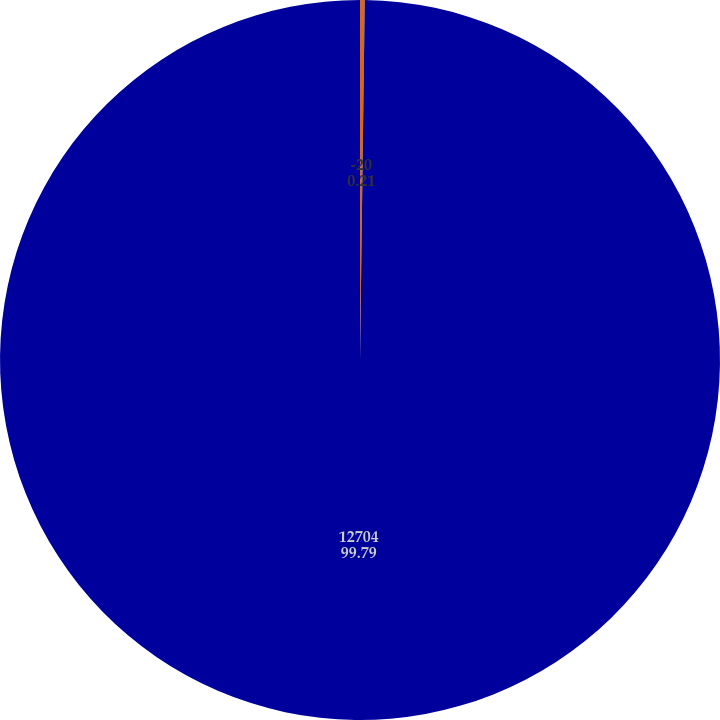Convert chart. <chart><loc_0><loc_0><loc_500><loc_500><pie_chart><fcel>-20<fcel>12704<nl><fcel>0.21%<fcel>99.79%<nl></chart> 